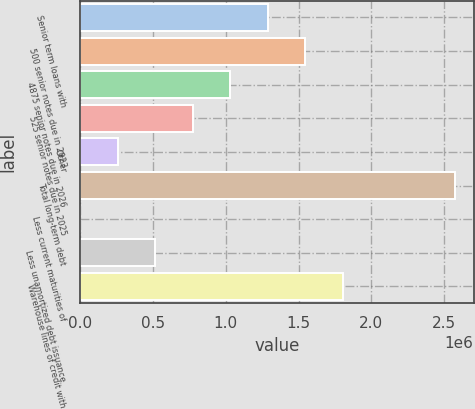Convert chart to OTSL. <chart><loc_0><loc_0><loc_500><loc_500><bar_chart><fcel>Senior term loans with<fcel>500 senior notes due in 2023<fcel>4875 senior notes due in 2026<fcel>525 senior notes due in 2025<fcel>Other<fcel>Total long-term debt<fcel>Less current maturities of<fcel>Less unamortized debt issuance<fcel>Warehouse lines of credit with<nl><fcel>1.28716e+06<fcel>1.54458e+06<fcel>1.02973e+06<fcel>772298<fcel>257440<fcel>2.5743e+06<fcel>11<fcel>514869<fcel>1.80201e+06<nl></chart> 